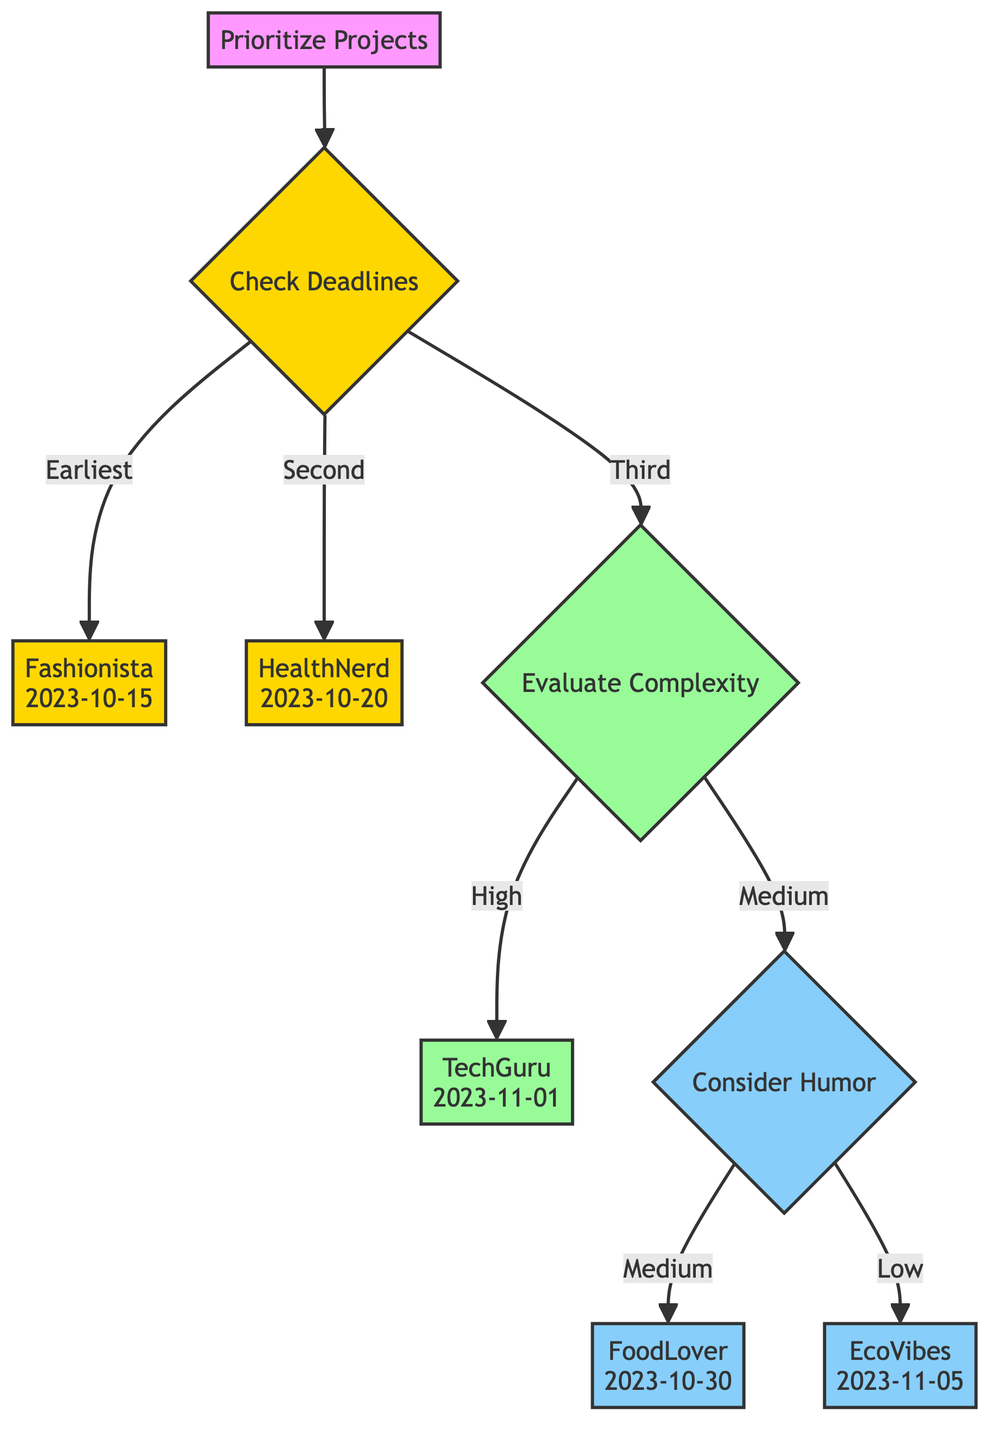What is the earliest project deadline in the diagram? The node representing the earliest project is "Fashionista," which has a deadline of "2023-10-15." By following the flow from the "Check Deadlines" node, it is clear that "Fashionista" is prioritized first due to having the earliest deadline.
Answer: 2023-10-15 Which project has the highest complexity? The highest complexity project in the diagram is indicated in the "Evaluate Complexity" step. It leads to "TechGuru," which has a complexity rating of "High." This is determined by the flow that shows "High" complexity being prioritized.
Answer: TechGuru How many nodes are involved in the decision-making process? The total number of nodes in the diagram consists of the start node and all subsequent nodes, leading to a count of seven distinct nodes: "Prioritize Projects," "Check Deadlines," "Evaluate Complexity," "Consider Humor," and the four different client projects at the leaves. This can be verified by counting each unique labeled shape in the flowchart.
Answer: 7 What comes after checking deadlines in the decision tree? After checking deadlines, the next step is "Evaluate Complexity." This follows directly from the decision tree structure where checking deadlines leads to this evaluation when deadlines are tied.
Answer: Evaluate Complexity Which project should be considered if two projects have the same deadline? If two projects share the same deadline, as per the logic presented in the decision tree, the project with higher complexity should be prioritized next. Following the flow, this condition leads us to the "Evaluate Complexity" step after the deadline check.
Answer: Higher Complexity Project Which project has a high humor potential but a low complexity? The project with a high humor potential rated as "High" but has a "Low" complexity is "HealthNerd." This is confirmed in the evaluation of other projects where "HealthNerd" fulfills both conditions.
Answer: HealthNerd What is the humor potential of the 'FoodLover' project? The humor potential of the 'FoodLover' project is specified in the decision nodes, showing it corresponds to a "Medium" potential. This can be determined by locating the project node and reading its humor potential label.
Answer: Medium Which condition is considered last in the decision tree? The last condition considered in the decision tree is the "Humor Potential." This condition is assessed only after checking deadlines and evaluating complexity, according to the structured flow of the diagram.
Answer: Humor Potential 